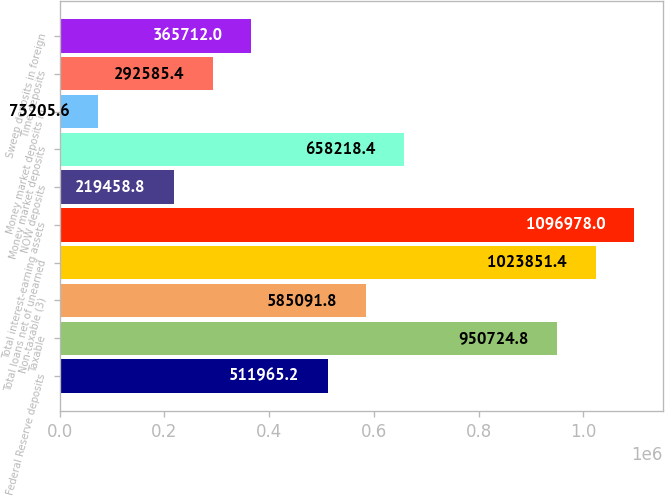Convert chart to OTSL. <chart><loc_0><loc_0><loc_500><loc_500><bar_chart><fcel>Federal Reserve deposits<fcel>Taxable<fcel>Non-taxable (3)<fcel>Total loans net of unearned<fcel>Total interest-earning assets<fcel>NOW deposits<fcel>Money market deposits<fcel>Money market deposits in<fcel>Time deposits<fcel>Sweep deposits in foreign<nl><fcel>511965<fcel>950725<fcel>585092<fcel>1.02385e+06<fcel>1.09698e+06<fcel>219459<fcel>658218<fcel>73205.6<fcel>292585<fcel>365712<nl></chart> 